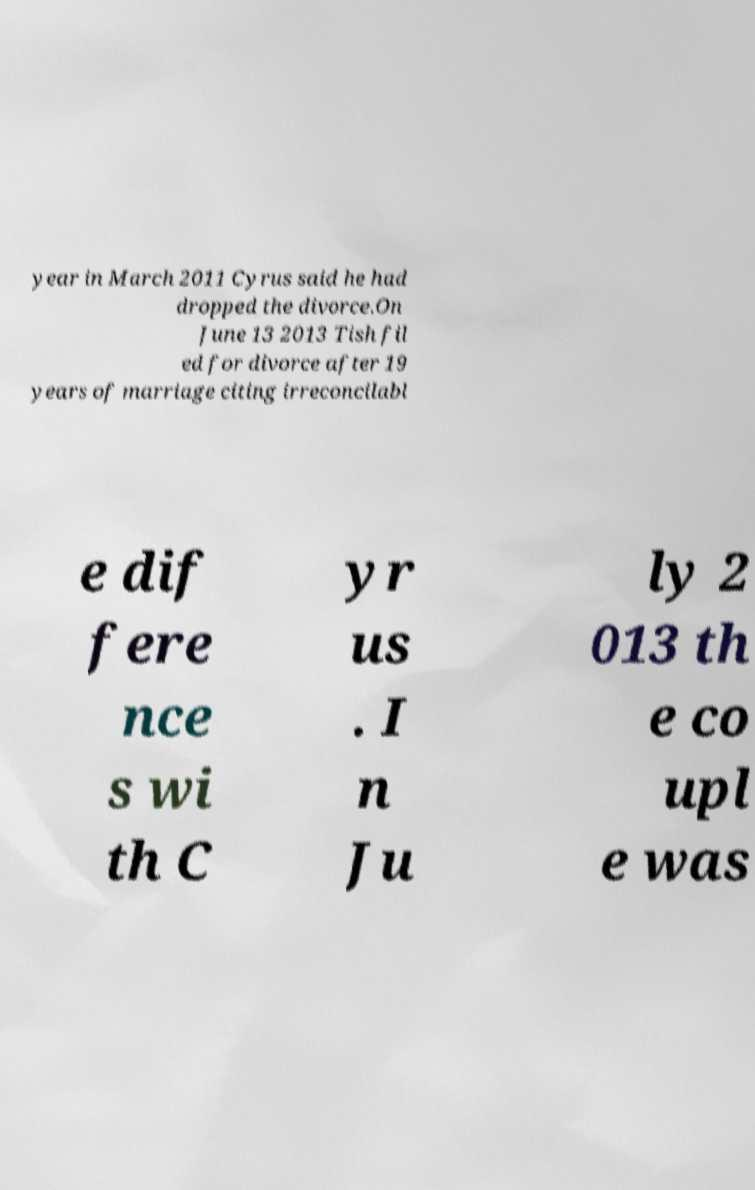Please read and relay the text visible in this image. What does it say? year in March 2011 Cyrus said he had dropped the divorce.On June 13 2013 Tish fil ed for divorce after 19 years of marriage citing irreconcilabl e dif fere nce s wi th C yr us . I n Ju ly 2 013 th e co upl e was 